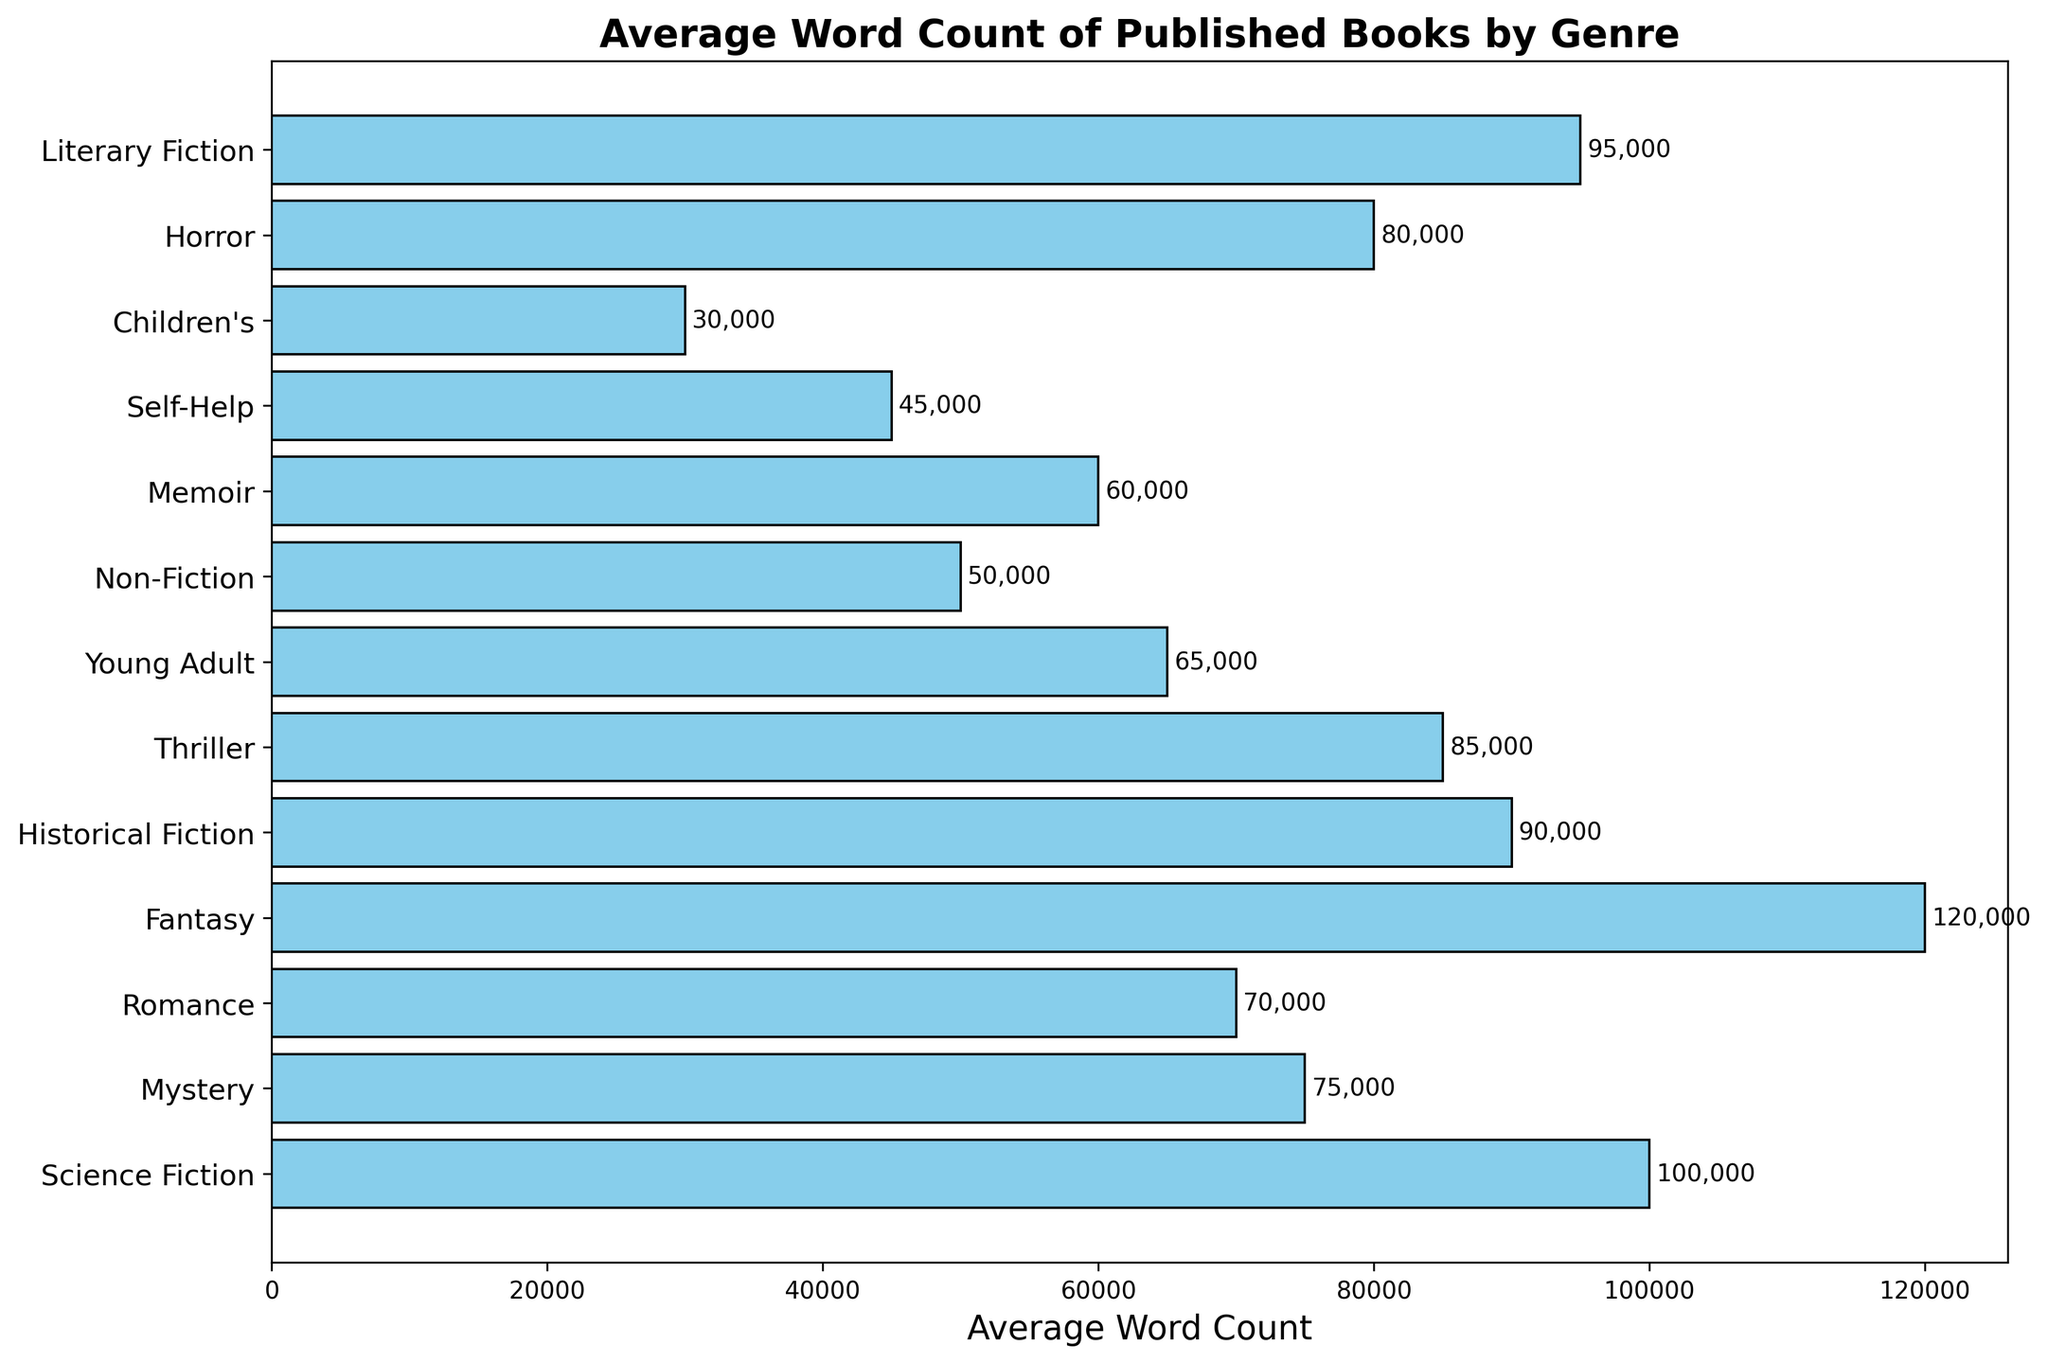What's the most common average word count range across the genres? By observing the figure, most genres have word counts ranging from 50,000 to 100,000.
Answer: 50,000 to 100,000 Which genre has the longest average word count and what is it? By examining the height/length of the bars, the Fantasy genre has the longest average word count at 120,000.
Answer: Fantasy, 120,000 How much higher is the average word count of Fantasy compared to Science Fiction? Fantasy has an average of 120,000 words, while Science Fiction has 100,000 words. The difference is 120,000 - 100,000 = 20,000 words.
Answer: 20,000 Which genre has a shorter average word count: Mystery or Historical Fiction? By comparing the lengths of bars, Mystery has an average word count of 75,000 and Historical Fiction has 90,000. Mystery is shorter.
Answer: Mystery What is the total average word count for Children's and Memoir combined? Children's has 30,000 and Memoir has 60,000. The total is 30,000 + 60,000 = 90,000.
Answer: 90,000 How does the average word count of Young Adult compare to Non-Fiction? Young Adult has 65,000 words, and Non-Fiction has 50,000. Young Adult has a higher average word count.
Answer: Young Adult is higher What genre has the lowest average word count and what is it? By observing the figure, Self-Help has the shortest bar, indicating the lowest average word count at 45,000.
Answer: Self-Help, 45,000 Which genres have an average word count above 80,000? Genres with average word counts above 80,000 include Science Fiction, Fantasy, Historical Fiction, Thriller, Horror, and Literary Fiction.
Answer: Science Fiction, Fantasy, Historical Fiction, Thriller, Horror, Literary Fiction What is the difference between the highest and lowest average word counts in the dataset? The highest average word count is Fantasy at 120,000 words and the lowest is Self-Help at 45,000 words. The difference is 120,000 - 45,000 = 75,000.
Answer: 75,000 